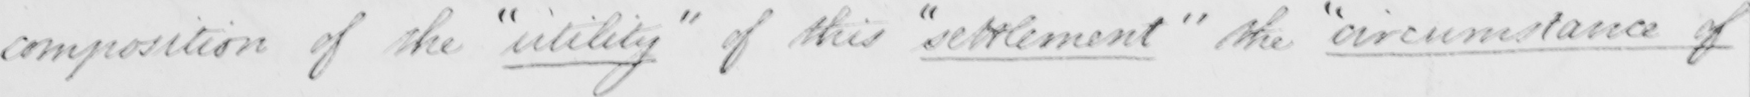Transcribe the text shown in this historical manuscript line. composition of the  " utility "  of this  " settlement "  the  " circumstances of 